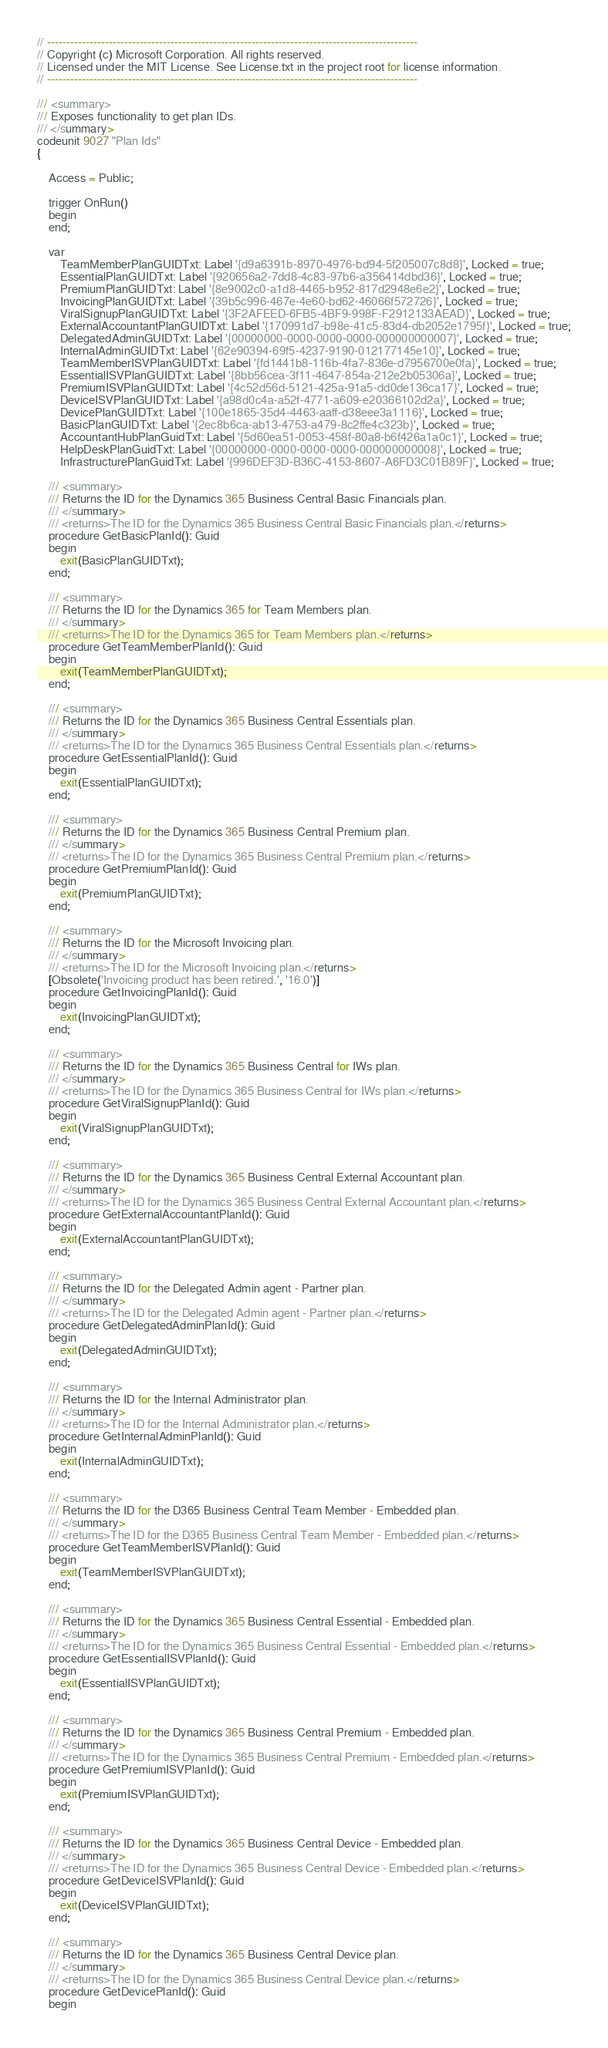Convert code to text. <code><loc_0><loc_0><loc_500><loc_500><_Perl_>// ------------------------------------------------------------------------------------------------
// Copyright (c) Microsoft Corporation. All rights reserved.
// Licensed under the MIT License. See License.txt in the project root for license information.
// ------------------------------------------------------------------------------------------------

/// <summary>
/// Exposes functionality to get plan IDs.
/// </summary>
codeunit 9027 "Plan Ids"
{

    Access = Public;

    trigger OnRun()
    begin
    end;

    var
        TeamMemberPlanGUIDTxt: Label '{d9a6391b-8970-4976-bd94-5f205007c8d8}', Locked = true;
        EssentialPlanGUIDTxt: Label '{920656a2-7dd8-4c83-97b6-a356414dbd36}', Locked = true;
        PremiumPlanGUIDTxt: Label '{8e9002c0-a1d8-4465-b952-817d2948e6e2}', Locked = true;
        InvoicingPlanGUIDTxt: Label '{39b5c996-467e-4e60-bd62-46066f572726}', Locked = true;
        ViralSignupPlanGUIDTxt: Label '{3F2AFEED-6FB5-4BF9-998F-F2912133AEAD}', Locked = true;
        ExternalAccountantPlanGUIDTxt: Label '{170991d7-b98e-41c5-83d4-db2052e1795f}', Locked = true;
        DelegatedAdminGUIDTxt: Label '{00000000-0000-0000-0000-000000000007}', Locked = true;
        InternalAdminGUIDTxt: Label '{62e90394-69f5-4237-9190-012177145e10}', Locked = true;
        TeamMemberISVPlanGUIDTxt: Label '{fd1441b8-116b-4fa7-836e-d7956700e0fa}', Locked = true;
        EssentialISVPlanGUIDTxt: Label '{8bb56cea-3f11-4647-854a-212e2b05306a}', Locked = true;
        PremiumISVPlanGUIDTxt: Label '{4c52d56d-5121-425a-91a5-dd0de136ca17}', Locked = true;
        DeviceISVPlanGUIDTxt: Label '{a98d0c4a-a52f-4771-a609-e20366102d2a}', Locked = true;
        DevicePlanGUIDTxt: Label '{100e1865-35d4-4463-aaff-d38eee3a1116}', Locked = true;
        BasicPlanGUIDTxt: Label '{2ec8b6ca-ab13-4753-a479-8c2ffe4c323b}', Locked = true;
        AccountantHubPlanGuidTxt: Label '{5d60ea51-0053-458f-80a8-b6f426a1a0c1}', Locked = true;
        HelpDeskPlanGuidTxt: Label '{00000000-0000-0000-0000-000000000008}', Locked = true;
        InfrastructurePlanGuidTxt: Label '{996DEF3D-B36C-4153-8607-A6FD3C01B89F}', Locked = true;

    /// <summary>
    /// Returns the ID for the Dynamics 365 Business Central Basic Financials plan.
    /// </summary>
    /// <returns>The ID for the Dynamics 365 Business Central Basic Financials plan.</returns>
    procedure GetBasicPlanId(): Guid
    begin
        exit(BasicPlanGUIDTxt);
    end;

    /// <summary>
    /// Returns the ID for the Dynamics 365 for Team Members plan.
    /// </summary>
    /// <returns>The ID for the Dynamics 365 for Team Members plan.</returns>
    procedure GetTeamMemberPlanId(): Guid
    begin
        exit(TeamMemberPlanGUIDTxt);
    end;

    /// <summary>
    /// Returns the ID for the Dynamics 365 Business Central Essentials plan.
    /// </summary>
    /// <returns>The ID for the Dynamics 365 Business Central Essentials plan.</returns>
    procedure GetEssentialPlanId(): Guid
    begin
        exit(EssentialPlanGUIDTxt);
    end;

    /// <summary>
    /// Returns the ID for the Dynamics 365 Business Central Premium plan.
    /// </summary>
    /// <returns>The ID for the Dynamics 365 Business Central Premium plan.</returns>
    procedure GetPremiumPlanId(): Guid
    begin
        exit(PremiumPlanGUIDTxt);
    end;

    /// <summary>
    /// Returns the ID for the Microsoft Invoicing plan.
    /// </summary>
    /// <returns>The ID for the Microsoft Invoicing plan.</returns>
    [Obsolete('Invoicing product has been retired.', '16.0')]
    procedure GetInvoicingPlanId(): Guid
    begin
        exit(InvoicingPlanGUIDTxt);
    end;

    /// <summary>
    /// Returns the ID for the Dynamics 365 Business Central for IWs plan.
    /// </summary>
    /// <returns>The ID for the Dynamics 365 Business Central for IWs plan.</returns>
    procedure GetViralSignupPlanId(): Guid
    begin
        exit(ViralSignupPlanGUIDTxt);
    end;

    /// <summary>
    /// Returns the ID for the Dynamics 365 Business Central External Accountant plan.
    /// </summary>
    /// <returns>The ID for the Dynamics 365 Business Central External Accountant plan.</returns>
    procedure GetExternalAccountantPlanId(): Guid
    begin
        exit(ExternalAccountantPlanGUIDTxt);
    end;

    /// <summary>
    /// Returns the ID for the Delegated Admin agent - Partner plan.
    /// </summary>
    /// <returns>The ID for the Delegated Admin agent - Partner plan.</returns>
    procedure GetDelegatedAdminPlanId(): Guid
    begin
        exit(DelegatedAdminGUIDTxt);
    end;

    /// <summary>
    /// Returns the ID for the Internal Administrator plan.
    /// </summary>
    /// <returns>The ID for the Internal Administrator plan.</returns>
    procedure GetInternalAdminPlanId(): Guid
    begin
        exit(InternalAdminGUIDTxt);
    end;

    /// <summary>
    /// Returns the ID for the D365 Business Central Team Member - Embedded plan.
    /// </summary>
    /// <returns>The ID for the D365 Business Central Team Member - Embedded plan.</returns>
    procedure GetTeamMemberISVPlanId(): Guid
    begin
        exit(TeamMemberISVPlanGUIDTxt);
    end;

    /// <summary>
    /// Returns the ID for the Dynamics 365 Business Central Essential - Embedded plan.
    /// </summary>
    /// <returns>The ID for the Dynamics 365 Business Central Essential - Embedded plan.</returns>
    procedure GetEssentialISVPlanId(): Guid
    begin
        exit(EssentialISVPlanGUIDTxt);
    end;

    /// <summary>
    /// Returns the ID for the Dynamics 365 Business Central Premium - Embedded plan.
    /// </summary>
    /// <returns>The ID for the Dynamics 365 Business Central Premium - Embedded plan.</returns>
    procedure GetPremiumISVPlanId(): Guid
    begin
        exit(PremiumISVPlanGUIDTxt);
    end;

    /// <summary>
    /// Returns the ID for the Dynamics 365 Business Central Device - Embedded plan.
    /// </summary>
    /// <returns>The ID for the Dynamics 365 Business Central Device - Embedded plan.</returns>
    procedure GetDeviceISVPlanId(): Guid
    begin
        exit(DeviceISVPlanGUIDTxt);
    end;

    /// <summary>
    /// Returns the ID for the Dynamics 365 Business Central Device plan.
    /// </summary>
    /// <returns>The ID for the Dynamics 365 Business Central Device plan.</returns>
    procedure GetDevicePlanId(): Guid
    begin</code> 